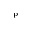Convert formula to latex. <formula><loc_0><loc_0><loc_500><loc_500>^ { p }</formula> 